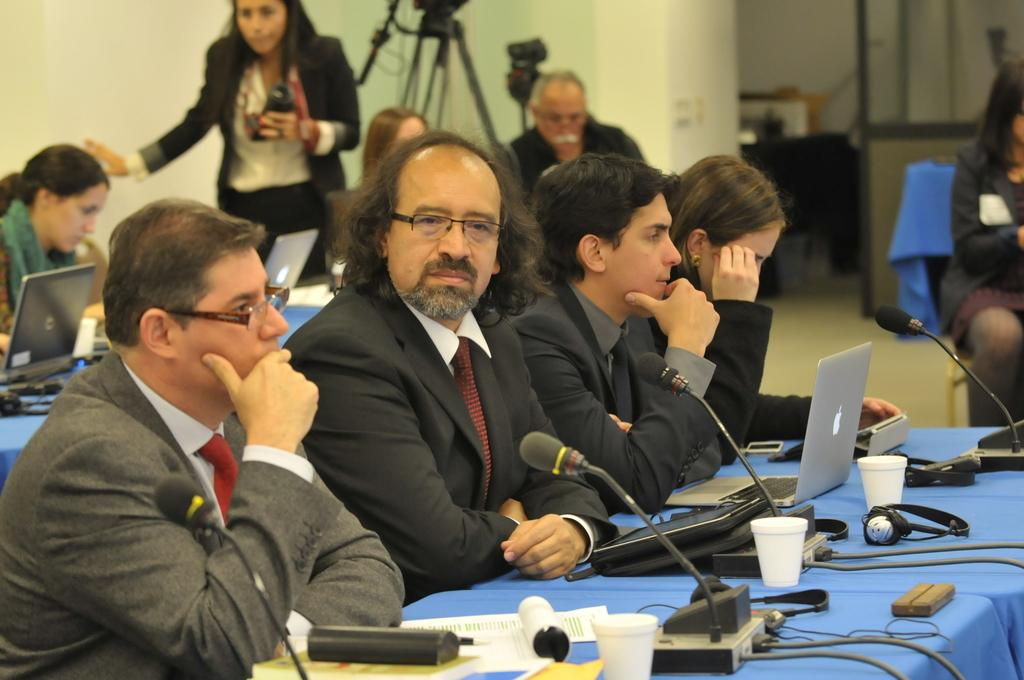Who or what can be seen in the image? There are persons in the image. What objects are present in the image? There are microphones and laptops in the image. Can you describe the setting of the image? There are other objects in the image, and there are persons and a wall in the background of the image. What other objects can be seen in the background of the image? There are other objects in the background of the image. Are there any other people visible in the image? Yes, there are persons in the background of the image. What type of waste can be seen in the image? There is no waste present in the image. Can you describe the cracker that is being used by one of the persons in the image? There is no cracker present in the image. 